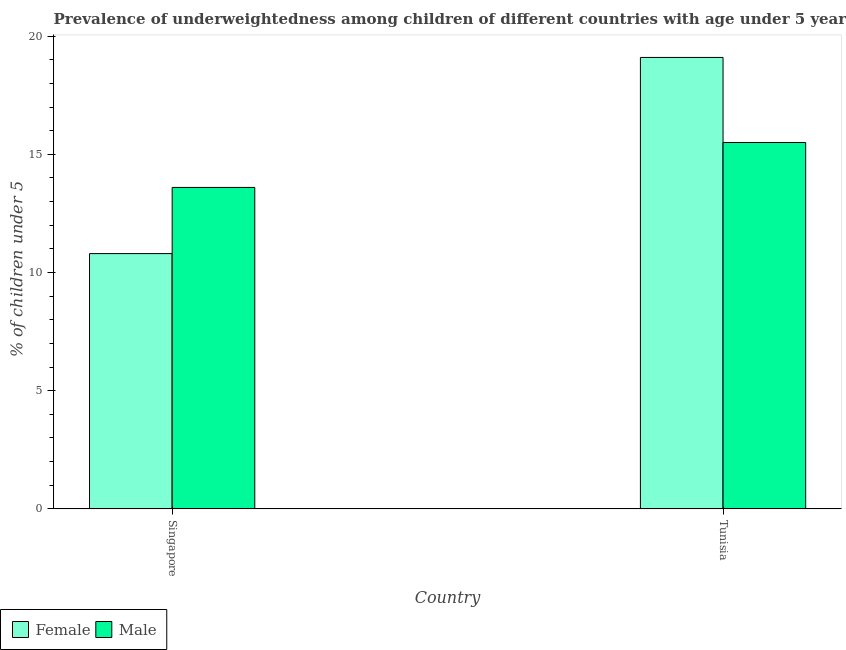How many different coloured bars are there?
Your answer should be compact. 2. How many groups of bars are there?
Your response must be concise. 2. How many bars are there on the 2nd tick from the left?
Keep it short and to the point. 2. How many bars are there on the 1st tick from the right?
Offer a very short reply. 2. What is the label of the 2nd group of bars from the left?
Provide a short and direct response. Tunisia. In how many cases, is the number of bars for a given country not equal to the number of legend labels?
Offer a very short reply. 0. What is the percentage of underweighted female children in Singapore?
Offer a terse response. 10.8. Across all countries, what is the minimum percentage of underweighted male children?
Your answer should be compact. 13.6. In which country was the percentage of underweighted male children maximum?
Provide a short and direct response. Tunisia. In which country was the percentage of underweighted female children minimum?
Provide a short and direct response. Singapore. What is the total percentage of underweighted male children in the graph?
Make the answer very short. 29.1. What is the difference between the percentage of underweighted male children in Singapore and that in Tunisia?
Offer a terse response. -1.9. What is the difference between the percentage of underweighted male children in Tunisia and the percentage of underweighted female children in Singapore?
Offer a very short reply. 4.7. What is the average percentage of underweighted female children per country?
Ensure brevity in your answer.  14.95. What is the difference between the percentage of underweighted female children and percentage of underweighted male children in Tunisia?
Give a very brief answer. 3.6. What is the ratio of the percentage of underweighted female children in Singapore to that in Tunisia?
Keep it short and to the point. 0.57. Is the percentage of underweighted female children in Singapore less than that in Tunisia?
Your answer should be very brief. Yes. In how many countries, is the percentage of underweighted female children greater than the average percentage of underweighted female children taken over all countries?
Keep it short and to the point. 1. What does the 1st bar from the left in Tunisia represents?
Offer a terse response. Female. How many bars are there?
Your response must be concise. 4. What is the difference between two consecutive major ticks on the Y-axis?
Provide a short and direct response. 5. Are the values on the major ticks of Y-axis written in scientific E-notation?
Offer a very short reply. No. Does the graph contain any zero values?
Provide a short and direct response. No. Where does the legend appear in the graph?
Offer a very short reply. Bottom left. How are the legend labels stacked?
Offer a very short reply. Horizontal. What is the title of the graph?
Offer a very short reply. Prevalence of underweightedness among children of different countries with age under 5 years. What is the label or title of the X-axis?
Offer a terse response. Country. What is the label or title of the Y-axis?
Offer a very short reply.  % of children under 5. What is the  % of children under 5 of Female in Singapore?
Offer a very short reply. 10.8. What is the  % of children under 5 of Male in Singapore?
Make the answer very short. 13.6. What is the  % of children under 5 in Female in Tunisia?
Your answer should be very brief. 19.1. Across all countries, what is the maximum  % of children under 5 in Female?
Ensure brevity in your answer.  19.1. Across all countries, what is the maximum  % of children under 5 in Male?
Provide a short and direct response. 15.5. Across all countries, what is the minimum  % of children under 5 of Female?
Provide a succinct answer. 10.8. Across all countries, what is the minimum  % of children under 5 in Male?
Provide a short and direct response. 13.6. What is the total  % of children under 5 in Female in the graph?
Offer a very short reply. 29.9. What is the total  % of children under 5 in Male in the graph?
Your answer should be compact. 29.1. What is the difference between the  % of children under 5 in Female in Singapore and that in Tunisia?
Keep it short and to the point. -8.3. What is the difference between the  % of children under 5 in Male in Singapore and that in Tunisia?
Your answer should be compact. -1.9. What is the average  % of children under 5 in Female per country?
Your answer should be compact. 14.95. What is the average  % of children under 5 of Male per country?
Offer a very short reply. 14.55. What is the ratio of the  % of children under 5 in Female in Singapore to that in Tunisia?
Keep it short and to the point. 0.57. What is the ratio of the  % of children under 5 in Male in Singapore to that in Tunisia?
Give a very brief answer. 0.88. What is the difference between the highest and the second highest  % of children under 5 of Female?
Make the answer very short. 8.3. What is the difference between the highest and the second highest  % of children under 5 in Male?
Offer a very short reply. 1.9. What is the difference between the highest and the lowest  % of children under 5 of Male?
Keep it short and to the point. 1.9. 